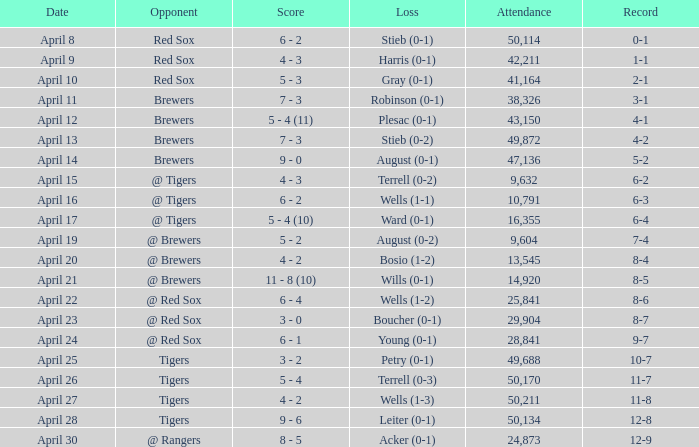Would you be able to parse every entry in this table? {'header': ['Date', 'Opponent', 'Score', 'Loss', 'Attendance', 'Record'], 'rows': [['April 8', 'Red Sox', '6 - 2', 'Stieb (0-1)', '50,114', '0-1'], ['April 9', 'Red Sox', '4 - 3', 'Harris (0-1)', '42,211', '1-1'], ['April 10', 'Red Sox', '5 - 3', 'Gray (0-1)', '41,164', '2-1'], ['April 11', 'Brewers', '7 - 3', 'Robinson (0-1)', '38,326', '3-1'], ['April 12', 'Brewers', '5 - 4 (11)', 'Plesac (0-1)', '43,150', '4-1'], ['April 13', 'Brewers', '7 - 3', 'Stieb (0-2)', '49,872', '4-2'], ['April 14', 'Brewers', '9 - 0', 'August (0-1)', '47,136', '5-2'], ['April 15', '@ Tigers', '4 - 3', 'Terrell (0-2)', '9,632', '6-2'], ['April 16', '@ Tigers', '6 - 2', 'Wells (1-1)', '10,791', '6-3'], ['April 17', '@ Tigers', '5 - 4 (10)', 'Ward (0-1)', '16,355', '6-4'], ['April 19', '@ Brewers', '5 - 2', 'August (0-2)', '9,604', '7-4'], ['April 20', '@ Brewers', '4 - 2', 'Bosio (1-2)', '13,545', '8-4'], ['April 21', '@ Brewers', '11 - 8 (10)', 'Wills (0-1)', '14,920', '8-5'], ['April 22', '@ Red Sox', '6 - 4', 'Wells (1-2)', '25,841', '8-6'], ['April 23', '@ Red Sox', '3 - 0', 'Boucher (0-1)', '29,904', '8-7'], ['April 24', '@ Red Sox', '6 - 1', 'Young (0-1)', '28,841', '9-7'], ['April 25', 'Tigers', '3 - 2', 'Petry (0-1)', '49,688', '10-7'], ['April 26', 'Tigers', '5 - 4', 'Terrell (0-3)', '50,170', '11-7'], ['April 27', 'Tigers', '4 - 2', 'Wells (1-3)', '50,211', '11-8'], ['April 28', 'Tigers', '9 - 6', 'Leiter (0-1)', '50,134', '12-8'], ['April 30', '@ Rangers', '8 - 5', 'Acker (0-1)', '24,873', '12-9']]} Which opponent has an attendance greater than 29,904 and 11-8 as the record? Tigers. 